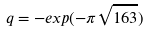<formula> <loc_0><loc_0><loc_500><loc_500>q = - e x p ( - \pi \sqrt { 1 6 3 } )</formula> 